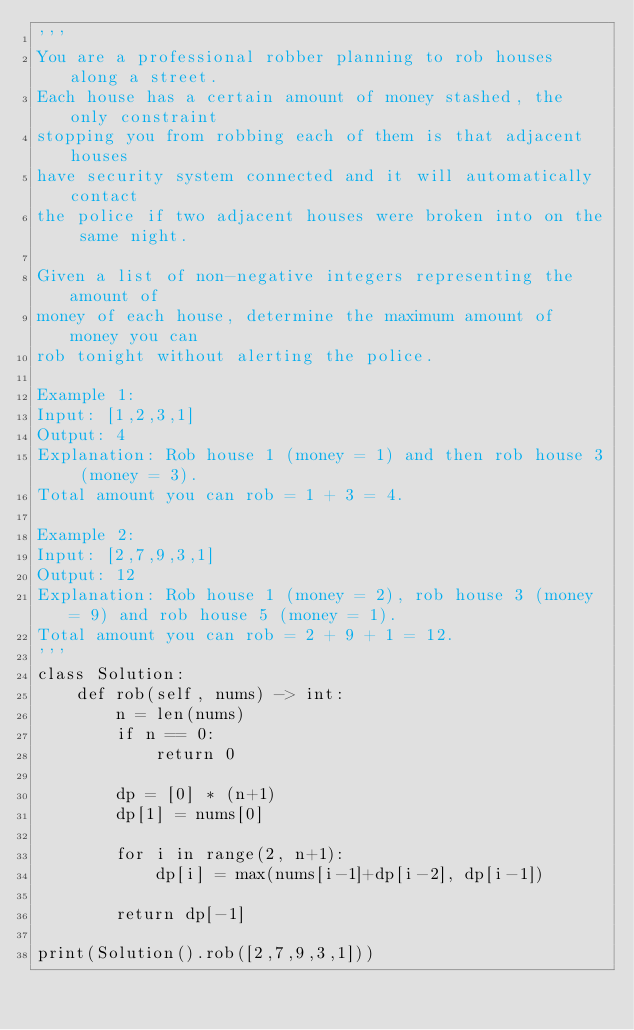Convert code to text. <code><loc_0><loc_0><loc_500><loc_500><_Python_>'''
You are a professional robber planning to rob houses along a street. 
Each house has a certain amount of money stashed, the only constraint 
stopping you from robbing each of them is that adjacent houses 
have security system connected and it will automatically contact 
the police if two adjacent houses were broken into on the same night.

Given a list of non-negative integers representing the amount of 
money of each house, determine the maximum amount of money you can 
rob tonight without alerting the police.

Example 1:
Input: [1,2,3,1]
Output: 4
Explanation: Rob house 1 (money = 1) and then rob house 3 (money = 3).
Total amount you can rob = 1 + 3 = 4.

Example 2:
Input: [2,7,9,3,1]
Output: 12
Explanation: Rob house 1 (money = 2), rob house 3 (money = 9) and rob house 5 (money = 1).
Total amount you can rob = 2 + 9 + 1 = 12.
'''
class Solution:
    def rob(self, nums) -> int:
        n = len(nums)
        if n == 0:
            return 0
        
        dp = [0] * (n+1)
        dp[1] = nums[0]

        for i in range(2, n+1):
            dp[i] = max(nums[i-1]+dp[i-2], dp[i-1])
        
        return dp[-1]

print(Solution().rob([2,7,9,3,1]))</code> 